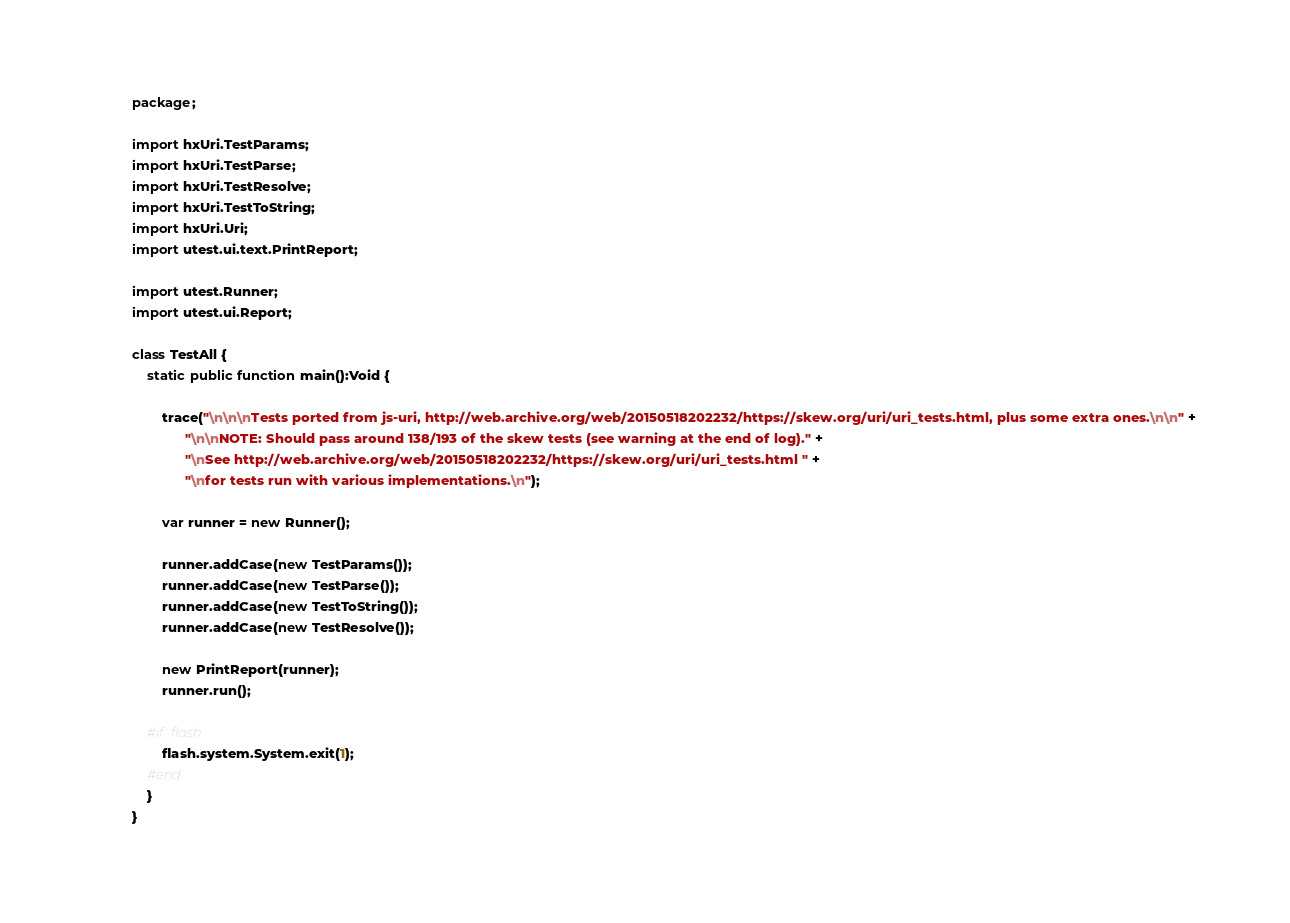<code> <loc_0><loc_0><loc_500><loc_500><_Haxe_>package;

import hxUri.TestParams;
import hxUri.TestParse;
import hxUri.TestResolve;
import hxUri.TestToString;
import hxUri.Uri;
import utest.ui.text.PrintReport;

import utest.Runner;
import utest.ui.Report;

class TestAll {
	static public function main():Void {
		
		trace("\n\n\nTests ported from js-uri, http://web.archive.org/web/20150518202232/https://skew.org/uri/uri_tests.html, plus some extra ones.\n\n" +
			  "\n\nNOTE: Should pass around 138/193 of the skew tests (see warning at the end of log)." +
			  "\nSee http://web.archive.org/web/20150518202232/https://skew.org/uri/uri_tests.html " +
			  "\nfor tests run with various implementations.\n");

		var runner = new Runner();
		
		runner.addCase(new TestParams());
		runner.addCase(new TestParse());
		runner.addCase(new TestToString());
		runner.addCase(new TestResolve());
		
		new PrintReport(runner);
		runner.run();
		
	#if flash
		flash.system.System.exit(1);
	#end
	}
}</code> 